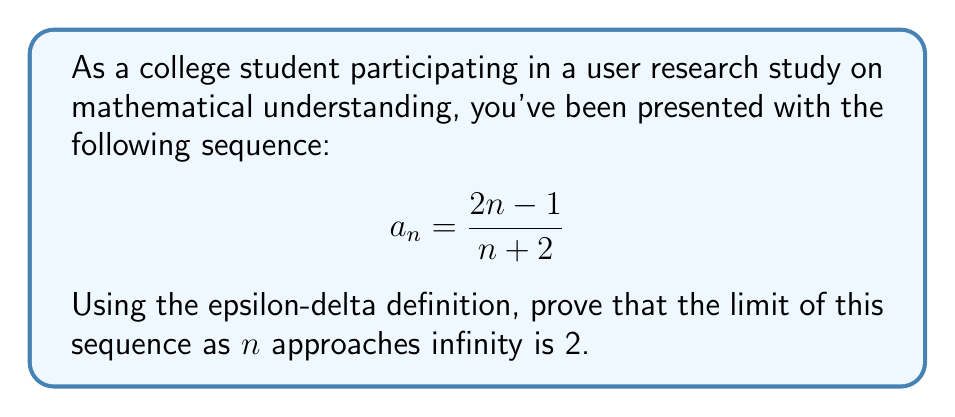Help me with this question. To prove that the limit of the sequence $a_n = \frac{2n-1}{n+2}$ is 2 as $n$ approaches infinity using the epsilon-delta definition, we need to show that for any $\epsilon > 0$, there exists a positive integer $N$ such that $|a_n - 2| < \epsilon$ for all $n \geq N$.

Step 1: Express $|a_n - 2|$ in terms of $n$.

$$\begin{align*}
|a_n - 2| &= \left|\frac{2n-1}{n+2} - 2\right| \\
&= \left|\frac{2n-1}{n+2} - \frac{2n+4}{n+2}\right| \\
&= \left|\frac{2n-1-2n-4}{n+2}\right| \\
&= \left|\frac{-5}{n+2}\right| \\
&= \frac{5}{n+2}
\end{align*}$$

Step 2: We want to find $N$ such that $\frac{5}{n+2} < \epsilon$ for all $n \geq N$.

Solving this inequality:

$$\begin{align*}
\frac{5}{n+2} &< \epsilon \\
5 &< \epsilon(n+2) \\
\frac{5}{\epsilon} - 2 &< n
\end{align*}$$

Step 3: Choose $N = \left\lfloor\frac{5}{\epsilon}\right\rfloor - 1$, where $\lfloor x \rfloor$ denotes the floor function (greatest integer less than or equal to $x$).

Step 4: Verify that this choice of $N$ works:

For all $n \geq N$:
$$n \geq \left\lfloor\frac{5}{\epsilon}\right\rfloor - 1 > \frac{5}{\epsilon} - 2$$

Therefore, $\frac{5}{n+2} < \epsilon$ for all $n \geq N$.

This proves that for any $\epsilon > 0$, we can find an $N$ such that $|a_n - 2| < \epsilon$ for all $n \geq N$, which is the epsilon-delta definition of the limit.
Answer: The limit of the sequence $a_n = \frac{2n-1}{n+2}$ as $n$ approaches infinity is 2, proven using the epsilon-delta definition with $N = \left\lfloor\frac{5}{\epsilon}\right\rfloor - 1$. 